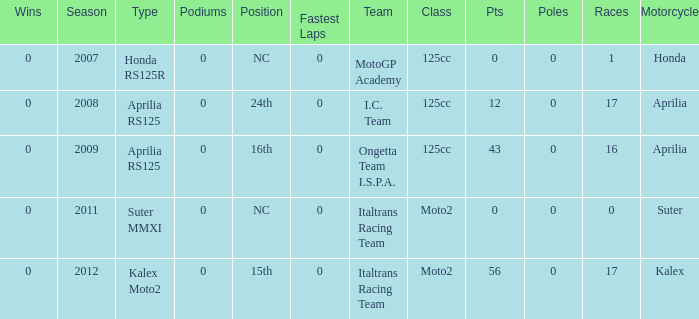What's the name of the team who had a Honda motorcycle? MotoGP Academy. 